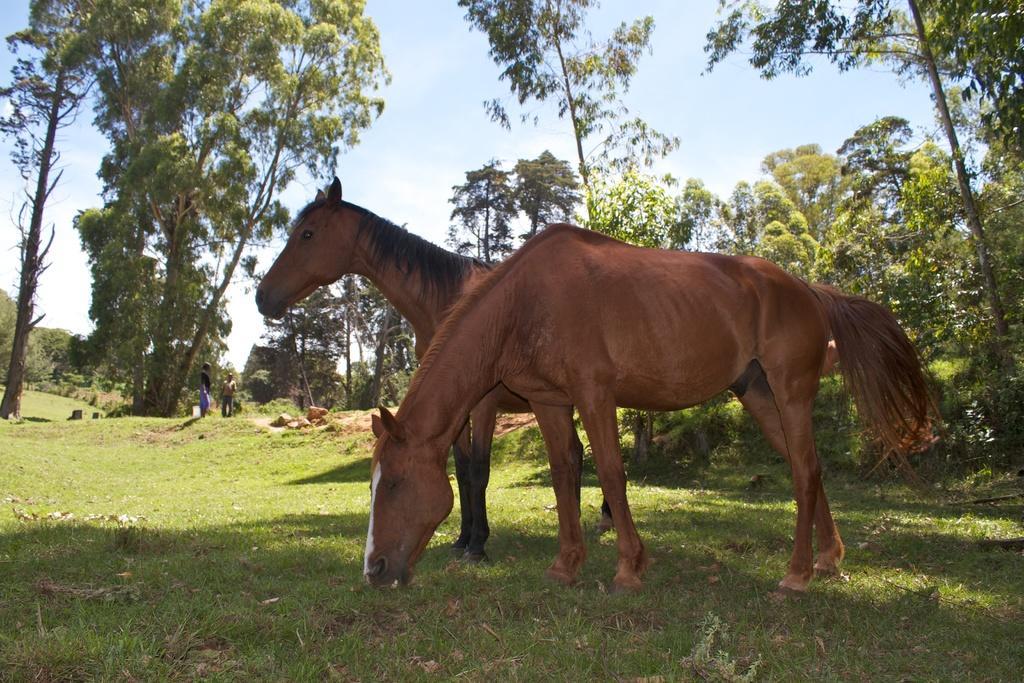Could you give a brief overview of what you see in this image? In the center of the image, we can see horses and in the background, there are trees and we can see people and there are rocks. At the top, there is sky and at the bottom, there is ground. 